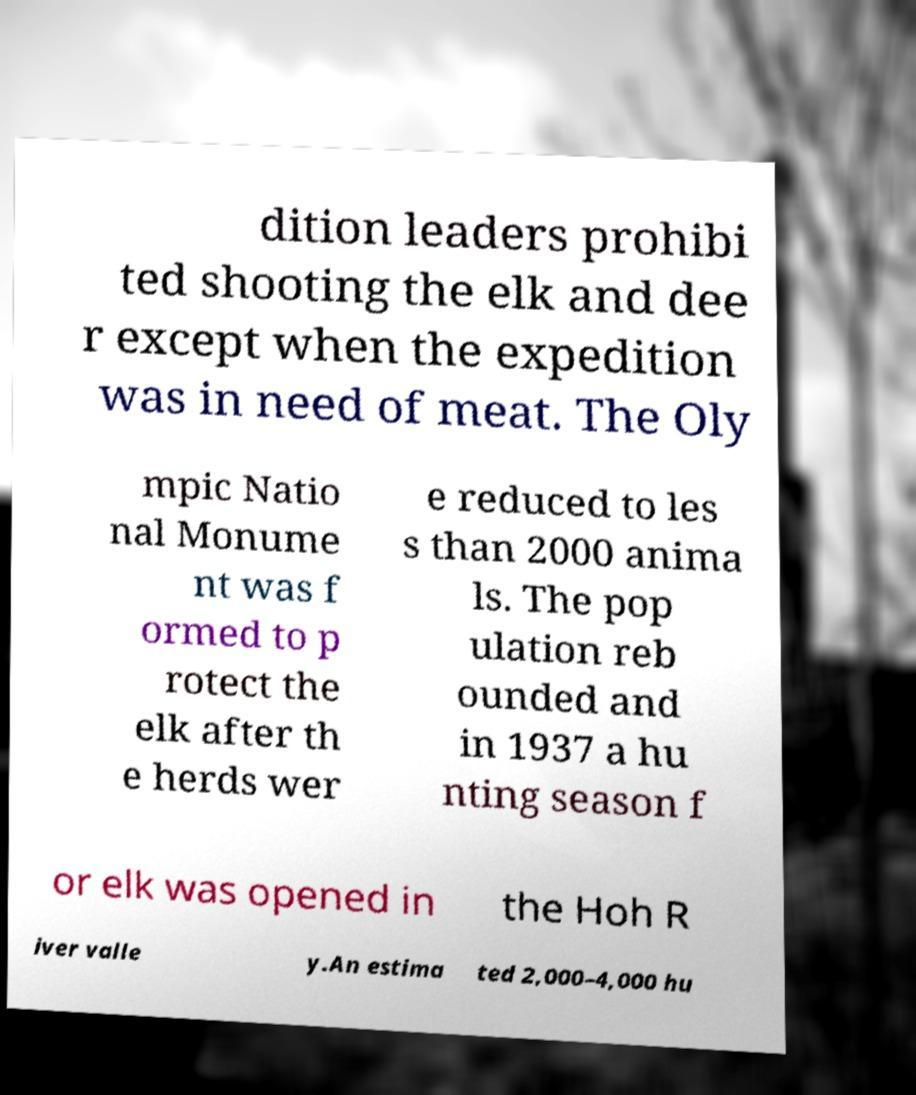Could you assist in decoding the text presented in this image and type it out clearly? dition leaders prohibi ted shooting the elk and dee r except when the expedition was in need of meat. The Oly mpic Natio nal Monume nt was f ormed to p rotect the elk after th e herds wer e reduced to les s than 2000 anima ls. The pop ulation reb ounded and in 1937 a hu nting season f or elk was opened in the Hoh R iver valle y.An estima ted 2,000–4,000 hu 